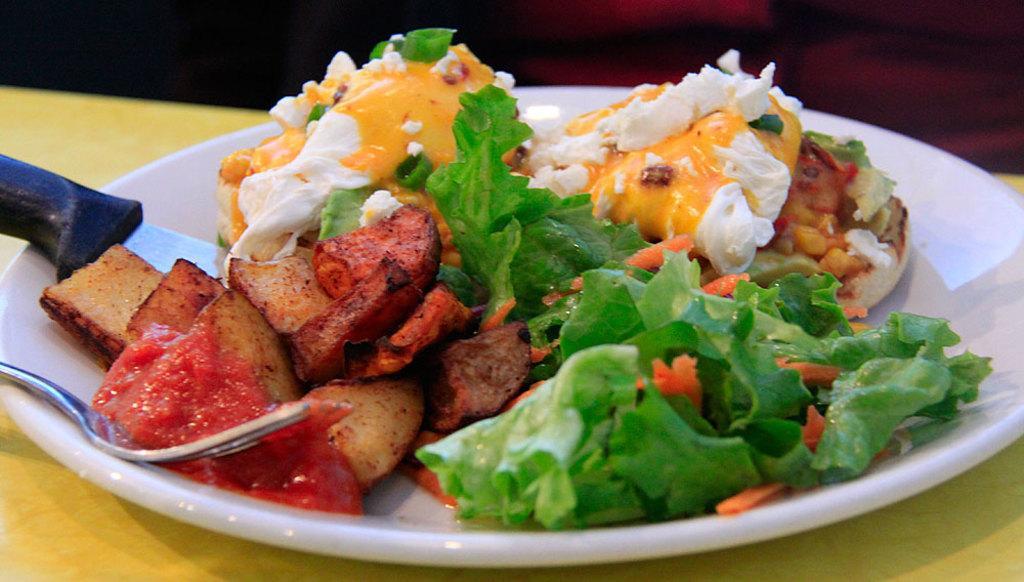Describe this image in one or two sentences. In this image there is food on the plate, there is a knife in the plate, fork on the plate, there is a plate on the surface. 